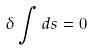Convert formula to latex. <formula><loc_0><loc_0><loc_500><loc_500>\delta \int d s = 0</formula> 